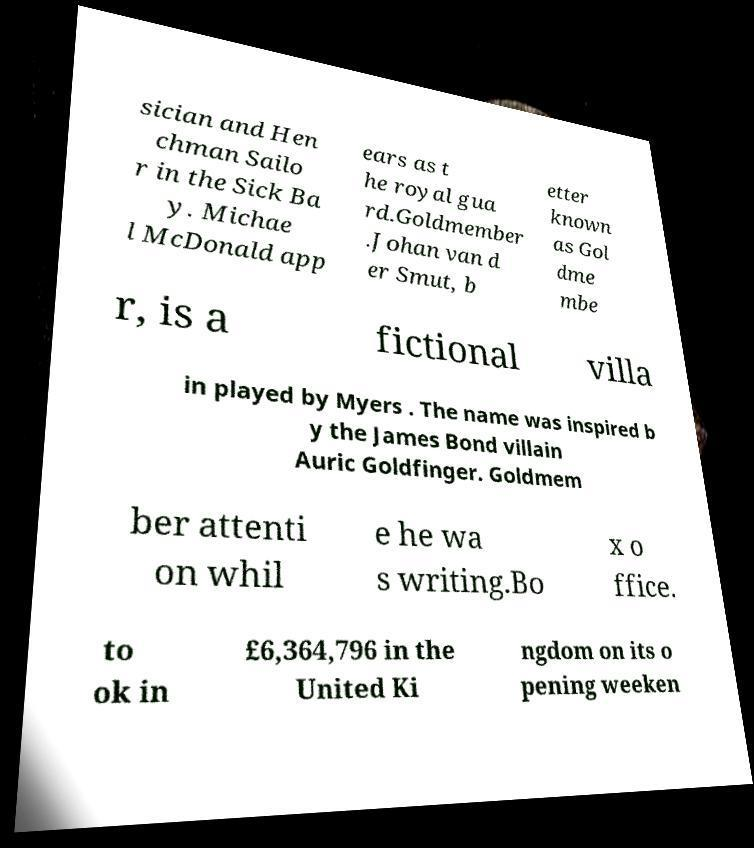Please identify and transcribe the text found in this image. sician and Hen chman Sailo r in the Sick Ba y. Michae l McDonald app ears as t he royal gua rd.Goldmember .Johan van d er Smut, b etter known as Gol dme mbe r, is a fictional villa in played by Myers . The name was inspired b y the James Bond villain Auric Goldfinger. Goldmem ber attenti on whil e he wa s writing.Bo x o ffice. to ok in £6,364,796 in the United Ki ngdom on its o pening weeken 